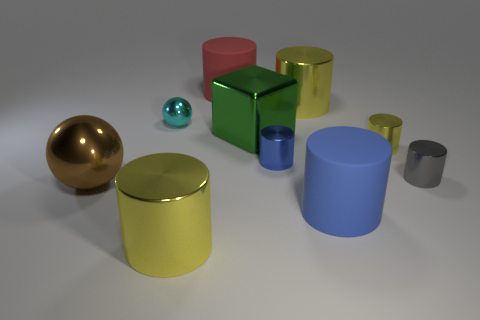There is a tiny object that is behind the yellow cylinder that is right of the blue matte cylinder; what is its shape?
Your answer should be compact. Sphere. Is there anything else that is the same color as the big sphere?
Your response must be concise. No. There is a brown metal thing; does it have the same size as the yellow cylinder to the left of the large red cylinder?
Keep it short and to the point. Yes. What number of small objects are brown rubber balls or green objects?
Offer a very short reply. 0. Are there more green objects than metal balls?
Make the answer very short. No. How many brown balls are to the left of the gray cylinder to the right of the metallic cylinder that is in front of the big blue object?
Make the answer very short. 1. The large red object is what shape?
Your answer should be compact. Cylinder. What number of other objects are the same material as the large brown sphere?
Ensure brevity in your answer.  7. Is the size of the red rubber cylinder the same as the blue metallic cylinder?
Your answer should be compact. No. There is a thing in front of the large blue matte thing; what shape is it?
Make the answer very short. Cylinder. 